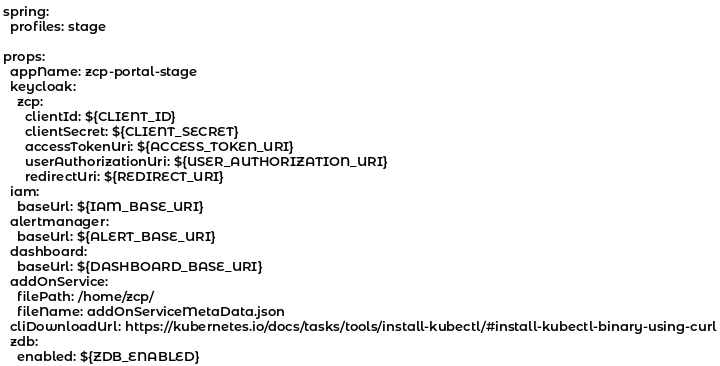<code> <loc_0><loc_0><loc_500><loc_500><_YAML_>spring:
  profiles: stage
  
props:
  appName: zcp-portal-stage
  keycloak:
    zcp:
      clientId: ${CLIENT_ID}
      clientSecret: ${CLIENT_SECRET}
      accessTokenUri: ${ACCESS_TOKEN_URI}
      userAuthorizationUri: ${USER_AUTHORIZATION_URI}
      redirectUri: ${REDIRECT_URI}
  iam:
    baseUrl: ${IAM_BASE_URI}
  alertmanager:
    baseUrl: ${ALERT_BASE_URI}
  dashboard:
    baseUrl: ${DASHBOARD_BASE_URI}
  addOnService:
    filePath: /home/zcp/
    fileName: addOnServiceMetaData.json
  cliDownloadUrl: https://kubernetes.io/docs/tasks/tools/install-kubectl/#install-kubectl-binary-using-curl
  zdb:
    enabled: ${ZDB_ENABLED}
</code> 